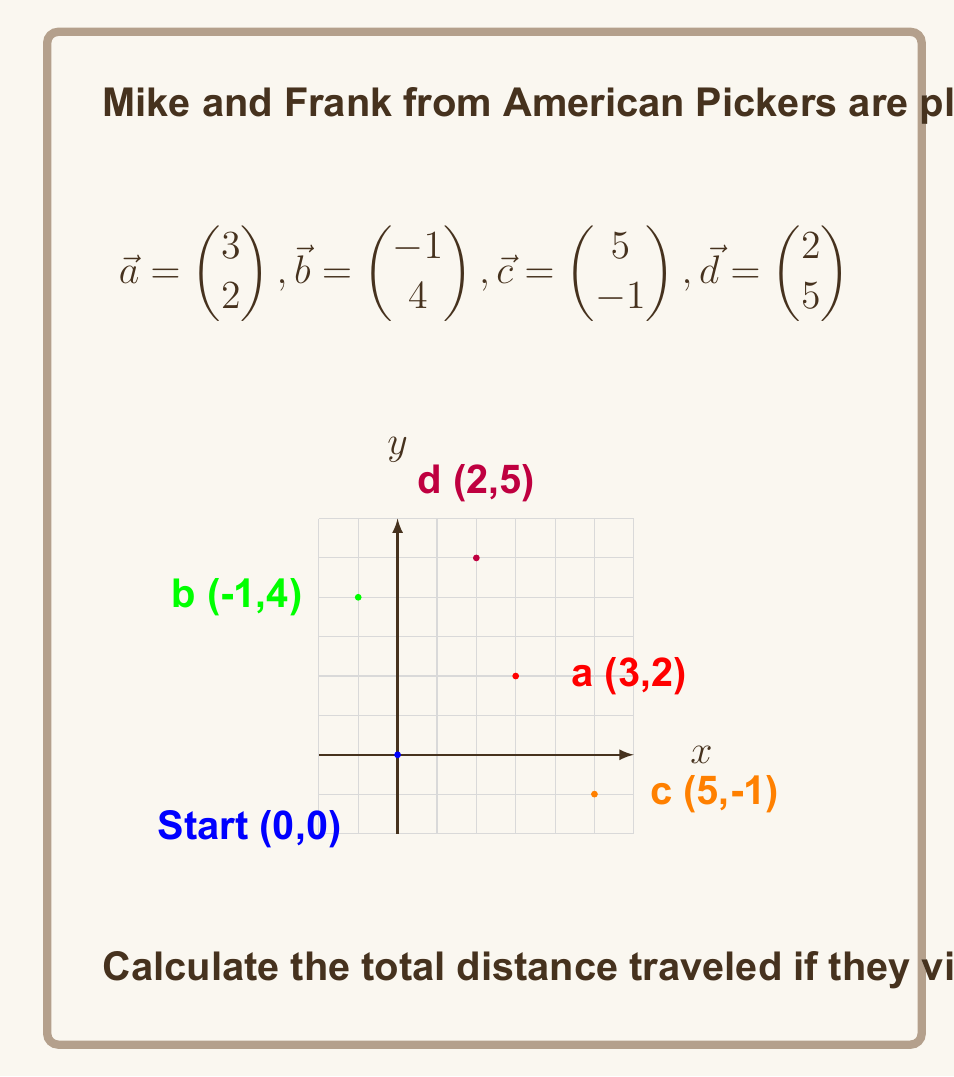Solve this math problem. To solve this problem, we need to calculate the distance between consecutive points in the route and sum them up. We'll use the distance formula derived from vector subtraction.

1. Distance from start to shop a:
   $|\vec{a}| = \sqrt{3^2 + 2^2} = \sqrt{13}$

2. Distance from shop a to shop b:
   $|\vec{b} - \vec{a}| = \left|\begin{pmatrix} -1-3 \\ 4-2 \end{pmatrix}\right| = \left|\begin{pmatrix} -4 \\ 2 \end{pmatrix}\right| = \sqrt{(-4)^2 + 2^2} = \sqrt{20}$

3. Distance from shop b to shop c:
   $|\vec{c} - \vec{b}| = \left|\begin{pmatrix} 5-(-1) \\ -1-4 \end{pmatrix}\right| = \left|\begin{pmatrix} 6 \\ -5 \end{pmatrix}\right| = \sqrt{6^2 + (-5)^2} = \sqrt{61}$

4. Distance from shop c to shop d:
   $|\vec{d} - \vec{c}| = \left|\begin{pmatrix} 2-5 \\ 5-(-1) \end{pmatrix}\right| = \left|\begin{pmatrix} -3 \\ 6 \end{pmatrix}\right| = \sqrt{(-3)^2 + 6^2} = \sqrt{45}$

5. Distance from shop d back to start:
   $|-\vec{d}| = \sqrt{2^2 + 5^2} = \sqrt{29}$

Total distance:
$\text{Total} = \sqrt{13} + \sqrt{20} + \sqrt{61} + \sqrt{45} + \sqrt{29}$

Using a calculator and rounding to the nearest tenth:
$\text{Total} \approx 3.6 + 4.5 + 7.8 + 6.7 + 5.4 = 28.0$
Answer: 28.0 units 